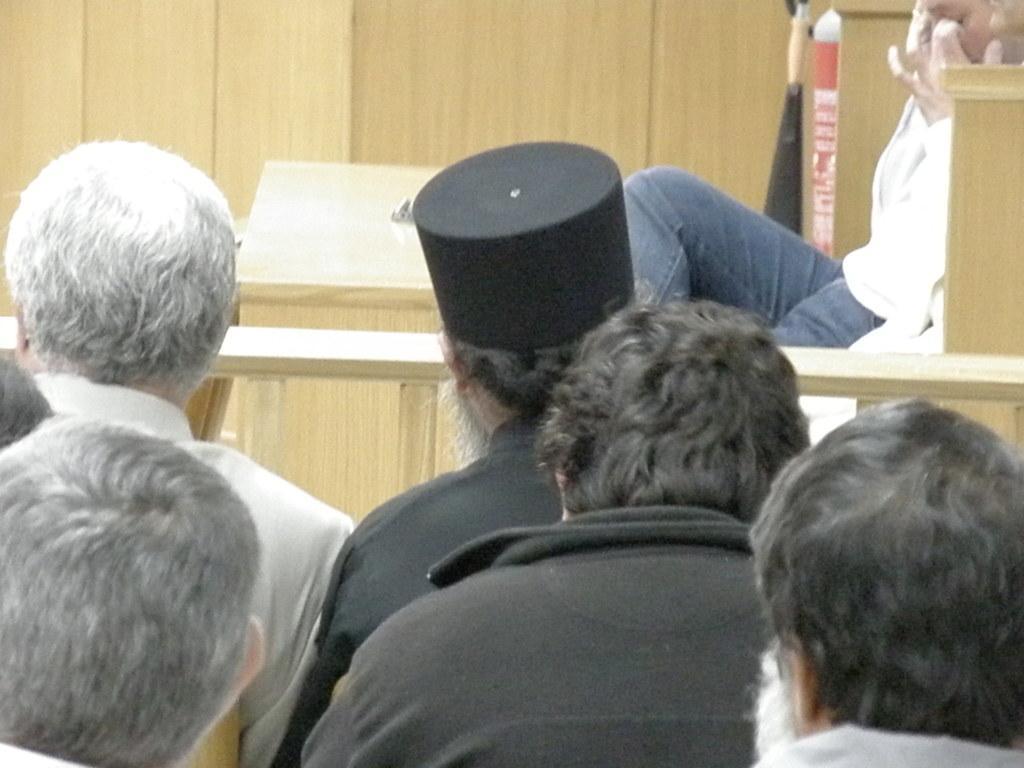Describe this image in one or two sentences. in this image I see few people and I see the cream color thing in the background. 